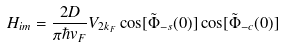<formula> <loc_0><loc_0><loc_500><loc_500>H _ { i m } = \frac { 2 D } { \pi \hbar { v } _ { F } } V _ { 2 k _ { F } } \cos [ \tilde { \Phi } _ { - s } ( 0 ) ] \cos [ \tilde { \Phi } _ { - c } ( 0 ) ]</formula> 